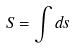Convert formula to latex. <formula><loc_0><loc_0><loc_500><loc_500>S = \int d s</formula> 